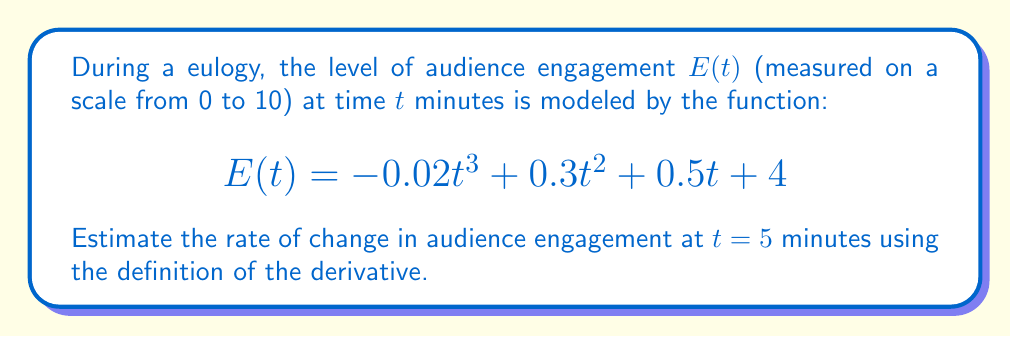Can you solve this math problem? To estimate the rate of change in audience engagement at $t = 5$ minutes, we'll use the definition of the derivative:

$$f'(a) = \lim_{h \to 0} \frac{f(a+h) - f(a)}{h}$$

1) Let $f(t) = E(t) = -0.02t^3 + 0.3t^2 + 0.5t + 4$ and $a = 5$

2) Calculate $f(5)$:
   $f(5) = -0.02(5^3) + 0.3(5^2) + 0.5(5) + 4$
   $f(5) = -2.5 + 7.5 + 2.5 + 4 = 11.5$

3) Calculate $f(5+h)$:
   $f(5+h) = -0.02(5+h)^3 + 0.3(5+h)^2 + 0.5(5+h) + 4$
   
4) Expand $f(5+h)$:
   $f(5+h) = -0.02(125 + 75h + 15h^2 + h^3) + 0.3(25 + 10h + h^2) + 0.5(5+h) + 4$
   $f(5+h) = -2.5 - 1.5h - 0.3h^2 - 0.02h^3 + 7.5 + 3h + 0.3h^2 + 2.5 + 0.5h + 4$
   $f(5+h) = 11.5 + 2h - 0.02h^3$

5) Calculate $\frac{f(5+h) - f(5)}{h}$:
   $\frac{f(5+h) - f(5)}{h} = \frac{(11.5 + 2h - 0.02h^3) - 11.5}{h} = 2 - 0.02h^2$

6) Take the limit as $h$ approaches 0:
   $\lim_{h \to 0} (2 - 0.02h^2) = 2$

Therefore, the rate of change in audience engagement at $t = 5$ minutes is approximately 2 units per minute.
Answer: 2 units/minute 